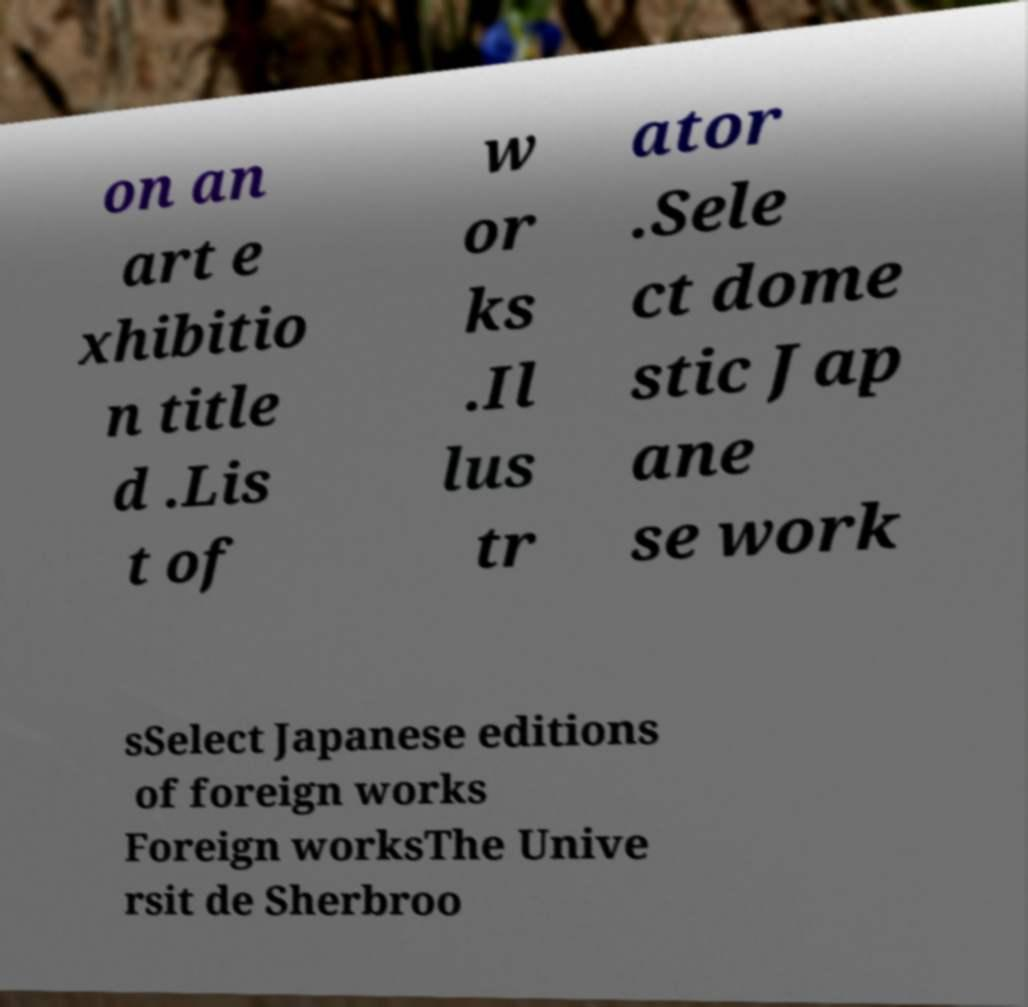Can you accurately transcribe the text from the provided image for me? on an art e xhibitio n title d .Lis t of w or ks .Il lus tr ator .Sele ct dome stic Jap ane se work sSelect Japanese editions of foreign works Foreign worksThe Unive rsit de Sherbroo 